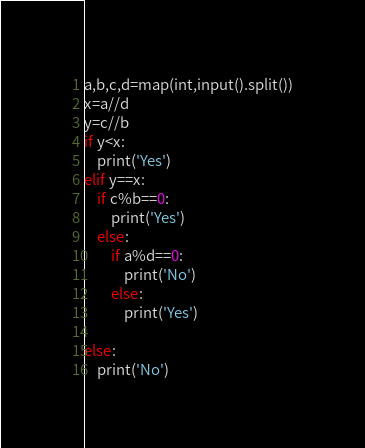<code> <loc_0><loc_0><loc_500><loc_500><_Python_>a,b,c,d=map(int,input().split())
x=a//d
y=c//b
if y<x:
    print('Yes')
elif y==x:
    if c%b==0:
        print('Yes')
    else:
        if a%d==0:
            print('No')
        else:
            print('Yes')
            
else:
    print('No')</code> 